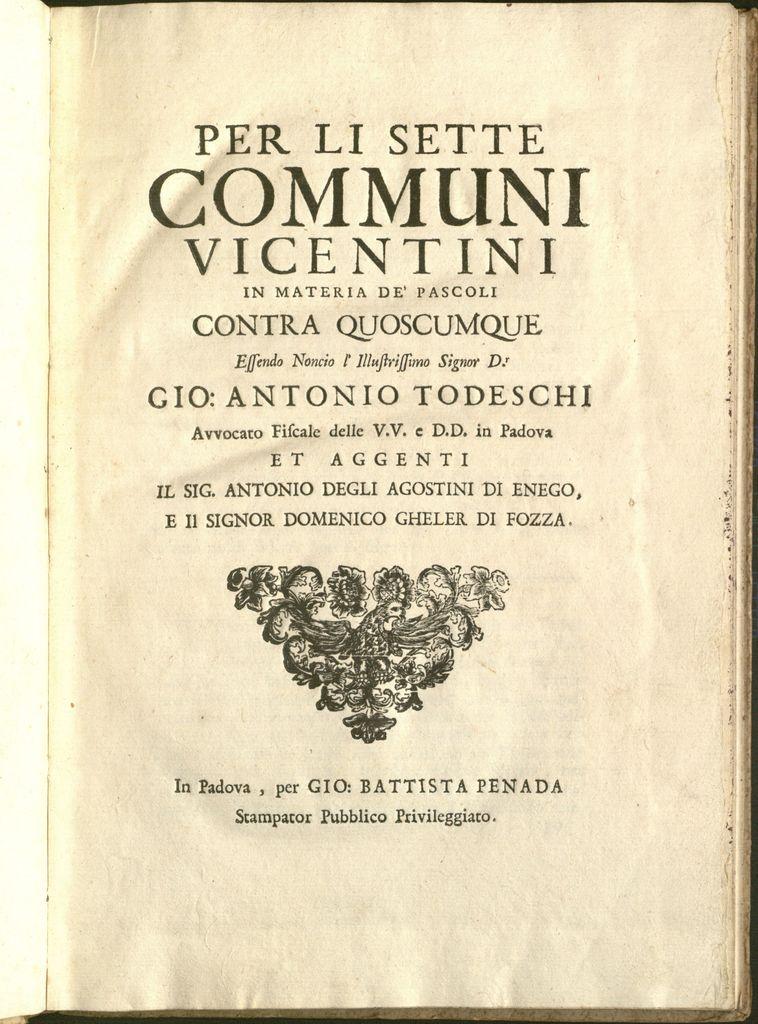What is the title of the book?
Offer a terse response. Per li sette communi vicentini. What is the name after gio:?
Offer a very short reply. Antonio todeschi. 